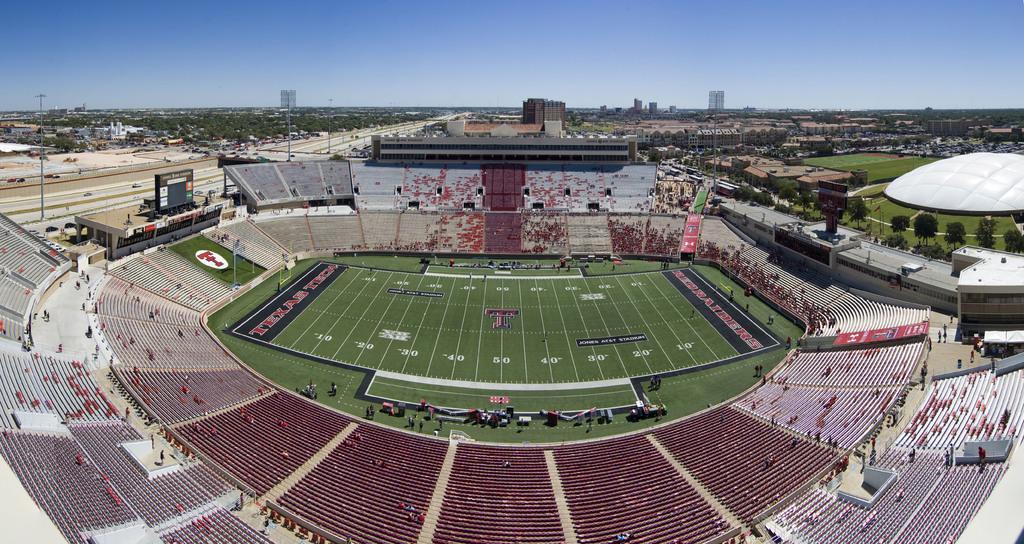In one or two sentences, can you explain what this image depicts? In the background we can see the sky, buildings, trees, poles and lights. In this picture we can see trees, vehicles on the road, grass. On the right side we can see an architecture in white color. This picture is mainly highlighted with a stadium. We can see people, stairs and banners. 